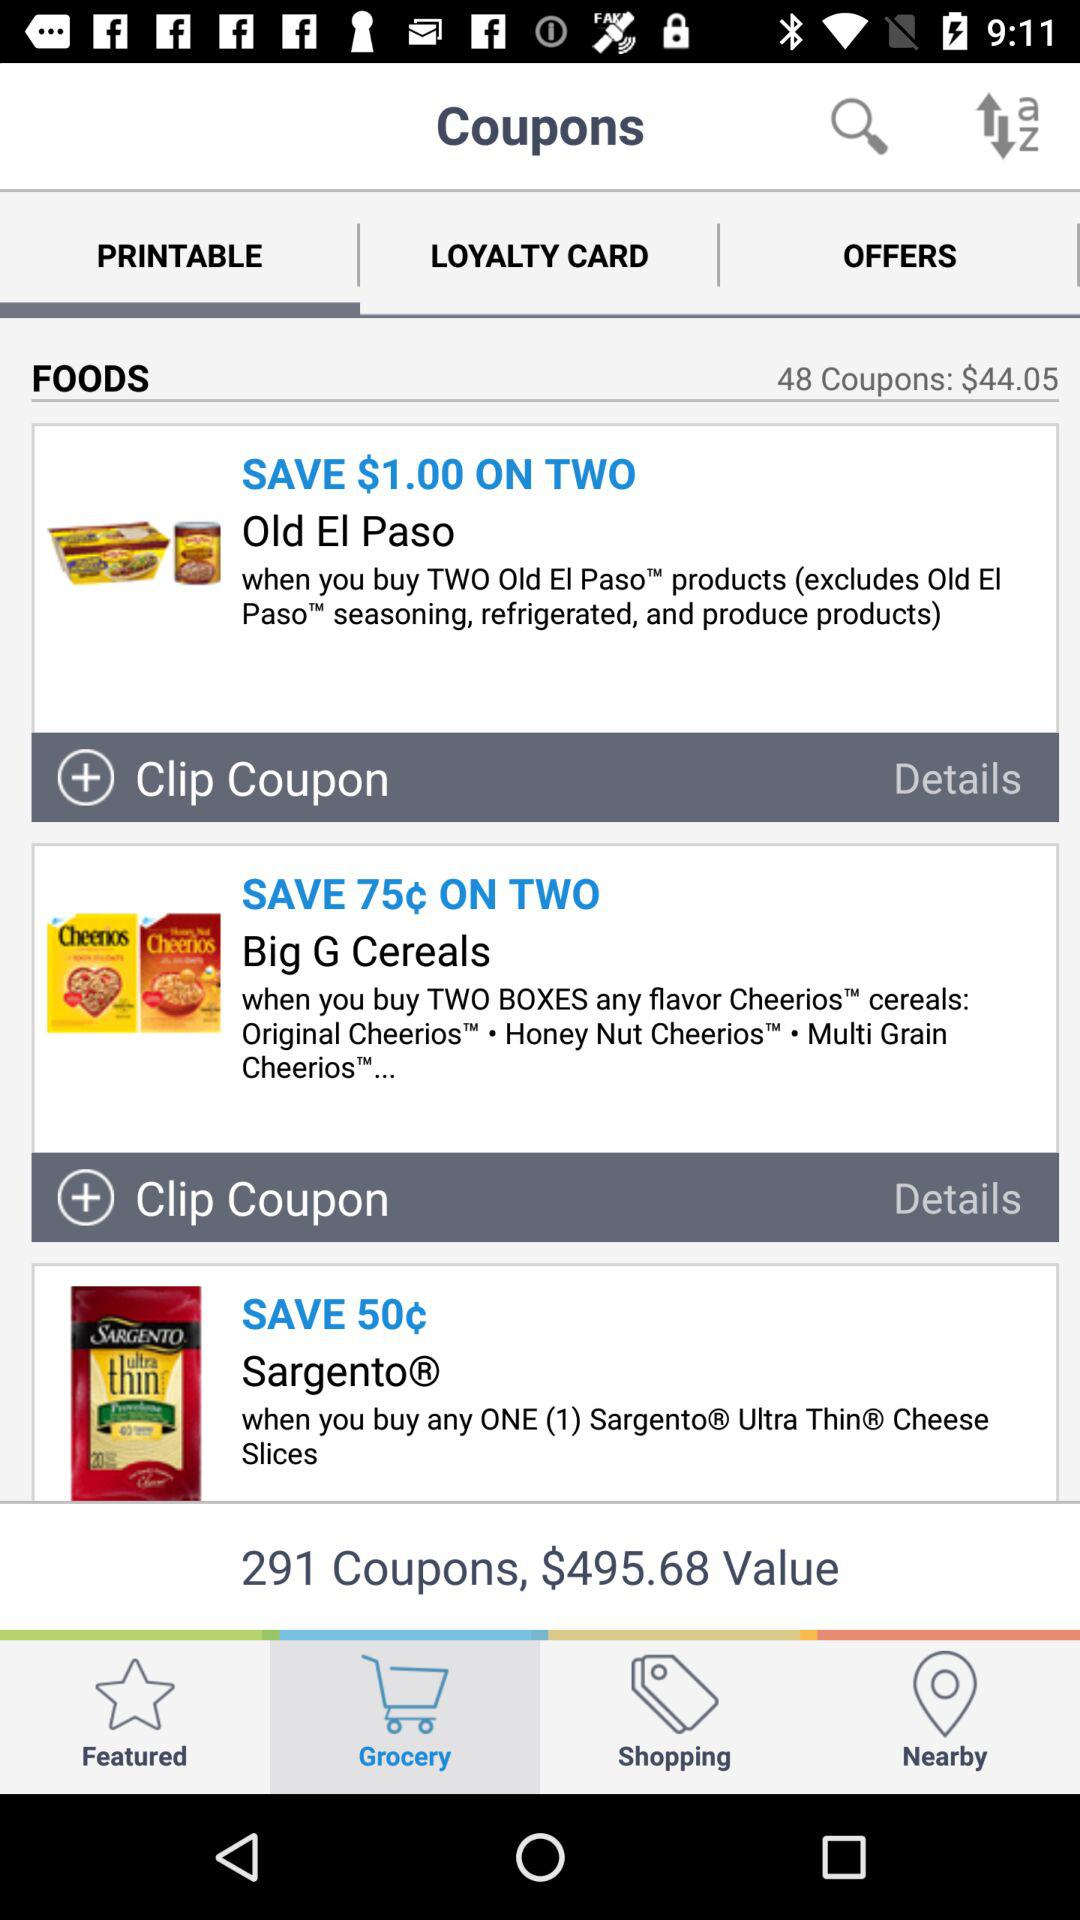What discount does "Sargento" offer on cheese slices? There is a discount of 50¢ on cheese slices. 